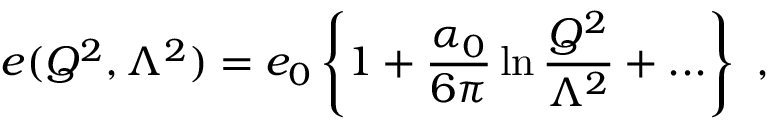<formula> <loc_0><loc_0><loc_500><loc_500>e ( Q ^ { 2 } , \Lambda ^ { 2 } ) = e _ { 0 } \left \{ 1 + \frac { \alpha _ { 0 } } { 6 \pi } \ln \frac { Q ^ { 2 } } { \Lambda ^ { 2 } } + \dots \right \} ,</formula> 